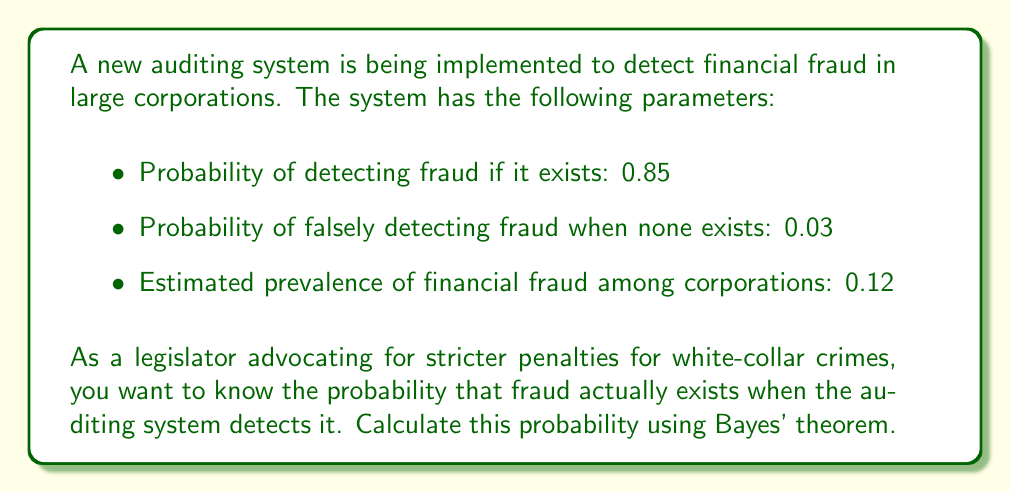Give your solution to this math problem. To solve this problem, we'll use Bayes' theorem. Let's define our events:

$F$: Fraud exists
$D$: Fraud is detected

We're given:
$P(D|F) = 0.85$ (probability of detecting fraud if it exists)
$P(D|\neg F) = 0.03$ (probability of falsely detecting fraud when none exists)
$P(F) = 0.12$ (prevalence of financial fraud)

We want to find $P(F|D)$ (probability that fraud exists given it was detected).

Bayes' theorem states:

$$P(F|D) = \frac{P(D|F) \cdot P(F)}{P(D)}$$

To find $P(D)$, we use the law of total probability:

$$P(D) = P(D|F) \cdot P(F) + P(D|\neg F) \cdot P(\neg F)$$

First, calculate $P(\neg F)$:
$P(\neg F) = 1 - P(F) = 1 - 0.12 = 0.88$

Now, calculate $P(D)$:
$$P(D) = 0.85 \cdot 0.12 + 0.03 \cdot 0.88 = 0.102 + 0.0264 = 0.1284$$

Finally, apply Bayes' theorem:

$$P(F|D) = \frac{0.85 \cdot 0.12}{0.1284} = \frac{0.102}{0.1284} \approx 0.7943$$
Answer: The probability that fraud actually exists when the auditing system detects it is approximately 0.7943 or 79.43%. 